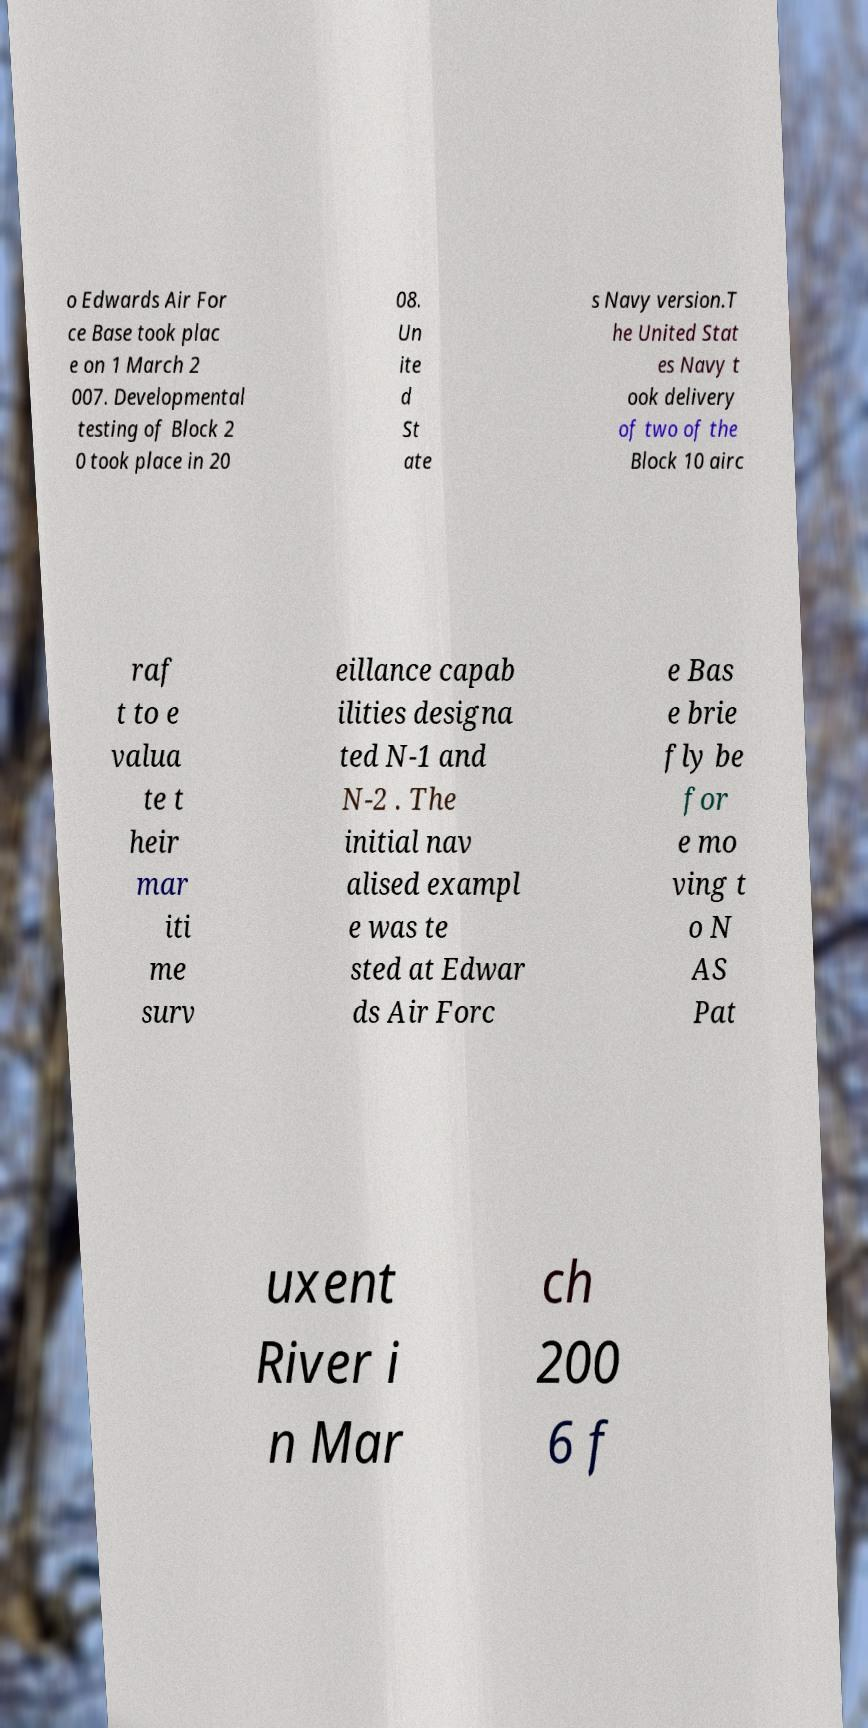I need the written content from this picture converted into text. Can you do that? o Edwards Air For ce Base took plac e on 1 March 2 007. Developmental testing of Block 2 0 took place in 20 08. Un ite d St ate s Navy version.T he United Stat es Navy t ook delivery of two of the Block 10 airc raf t to e valua te t heir mar iti me surv eillance capab ilities designa ted N-1 and N-2 . The initial nav alised exampl e was te sted at Edwar ds Air Forc e Bas e brie fly be for e mo ving t o N AS Pat uxent River i n Mar ch 200 6 f 